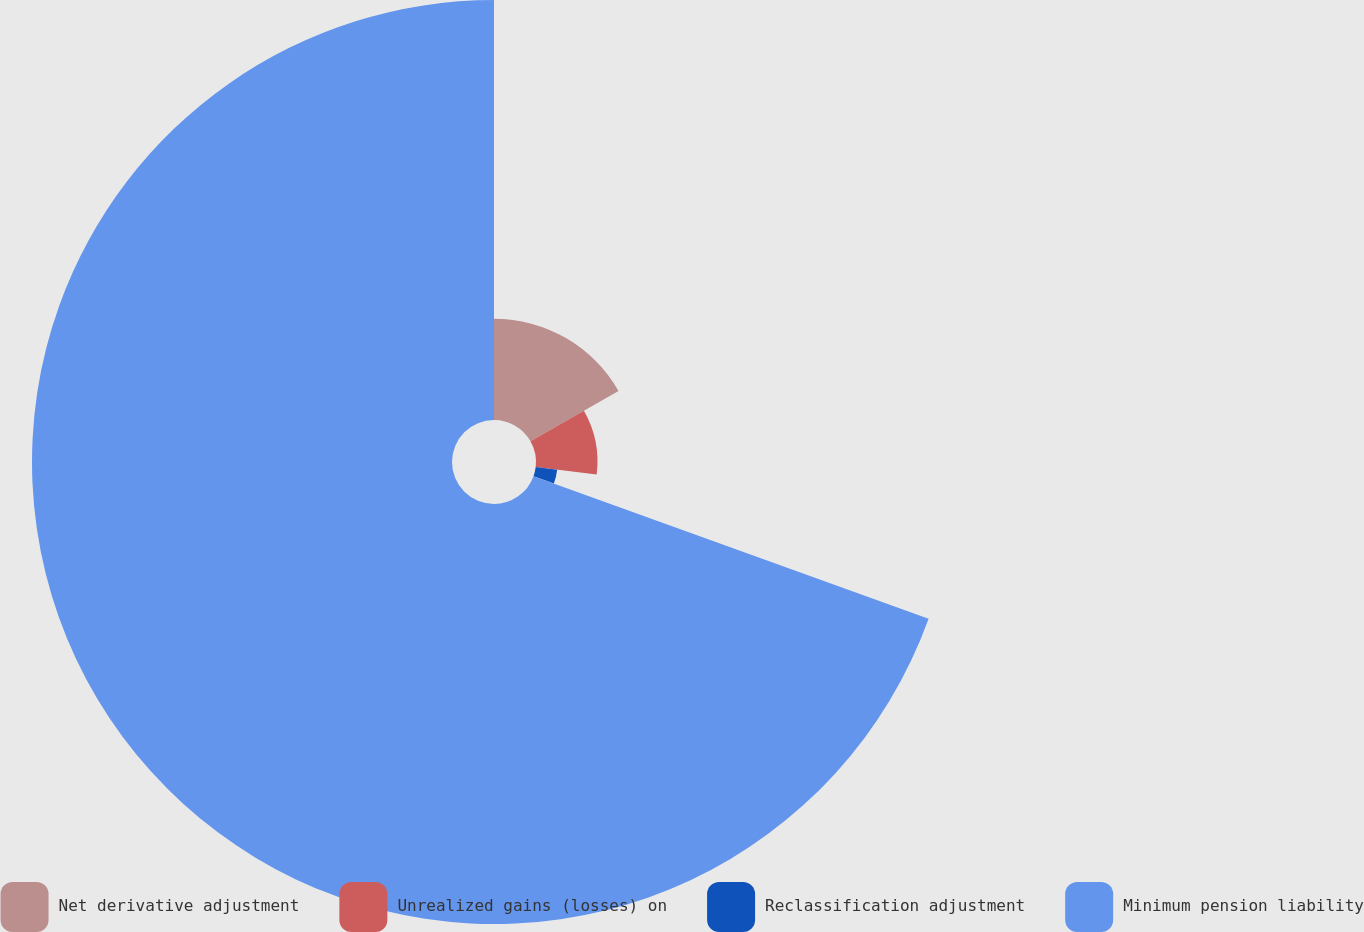<chart> <loc_0><loc_0><loc_500><loc_500><pie_chart><fcel>Net derivative adjustment<fcel>Unrealized gains (losses) on<fcel>Reclassification adjustment<fcel>Minimum pension liability<nl><fcel>16.76%<fcel>10.17%<fcel>3.58%<fcel>69.49%<nl></chart> 